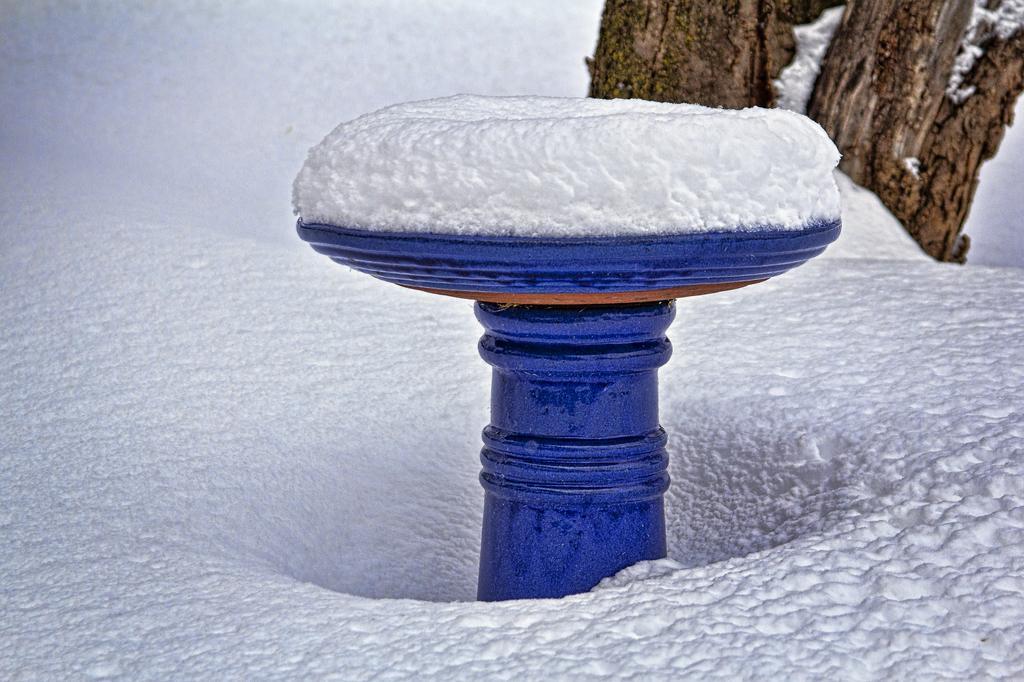How would you summarize this image in a sentence or two? In the background we can see tree trunks. On the blue object there is snow. At the bottom portion of the picture there is snow. 